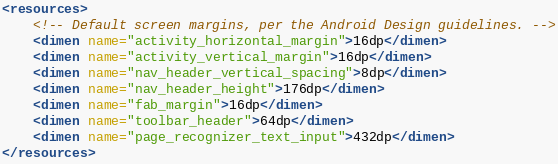Convert code to text. <code><loc_0><loc_0><loc_500><loc_500><_XML_><resources>
    <!-- Default screen margins, per the Android Design guidelines. -->
    <dimen name="activity_horizontal_margin">16dp</dimen>
    <dimen name="activity_vertical_margin">16dp</dimen>
    <dimen name="nav_header_vertical_spacing">8dp</dimen>
    <dimen name="nav_header_height">176dp</dimen>
    <dimen name="fab_margin">16dp</dimen>
    <dimen name="toolbar_header">64dp</dimen>
    <dimen name="page_recognizer_text_input">432dp</dimen>
</resources></code> 